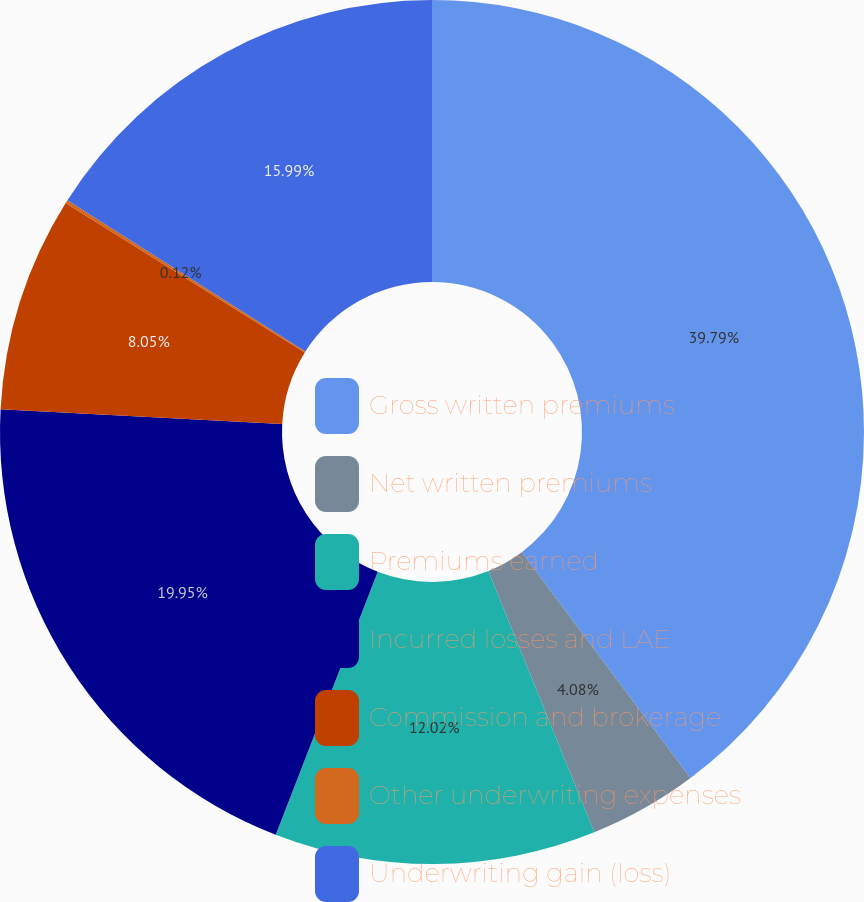Convert chart. <chart><loc_0><loc_0><loc_500><loc_500><pie_chart><fcel>Gross written premiums<fcel>Net written premiums<fcel>Premiums earned<fcel>Incurred losses and LAE<fcel>Commission and brokerage<fcel>Other underwriting expenses<fcel>Underwriting gain (loss)<nl><fcel>39.79%<fcel>4.08%<fcel>12.02%<fcel>19.95%<fcel>8.05%<fcel>0.12%<fcel>15.99%<nl></chart> 